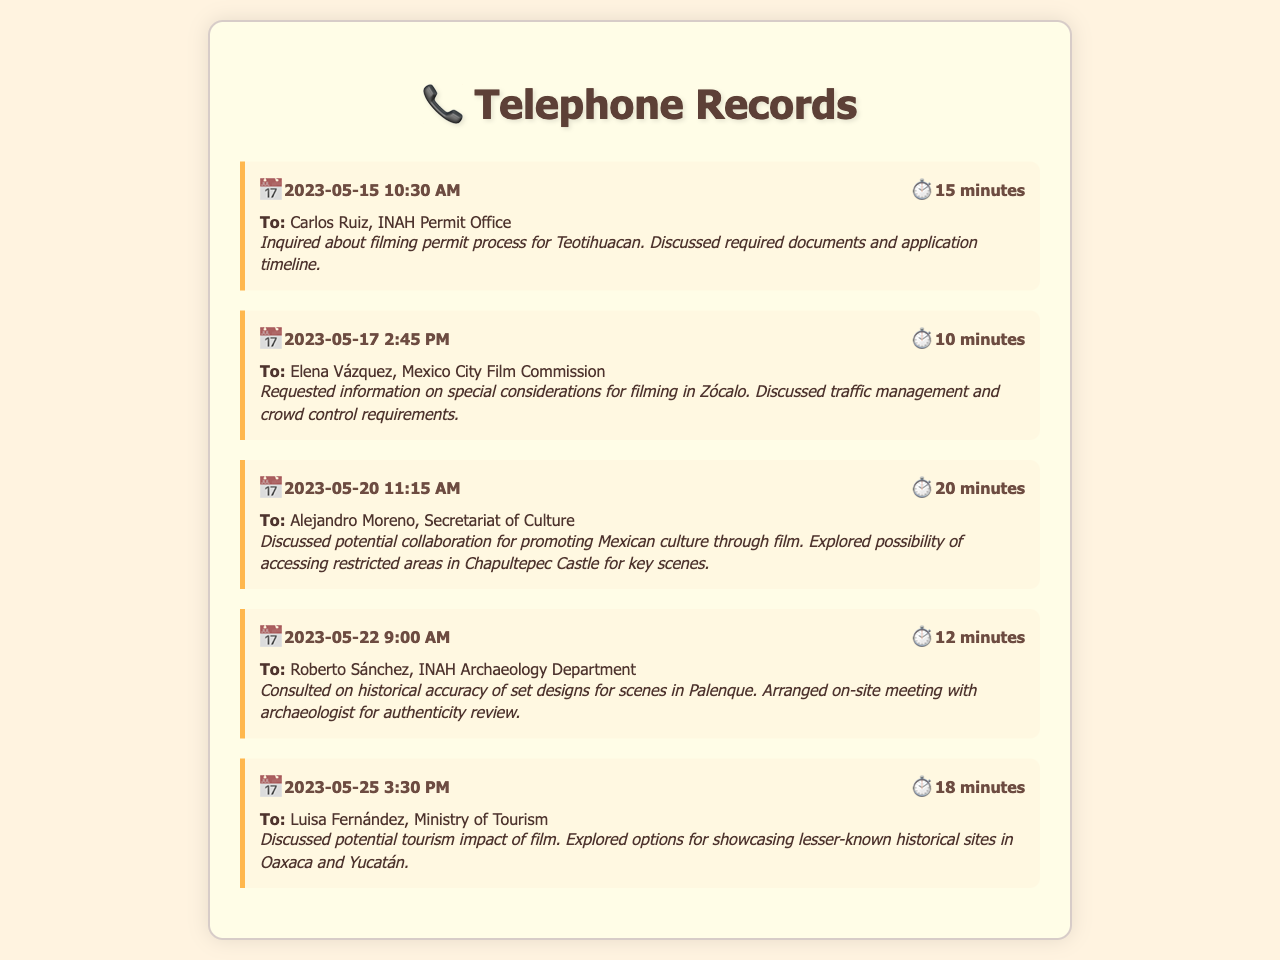What is the date of the first call? The date of the first call is mentioned in the call record as May 15, 2023.
Answer: May 15, 2023 Who did María González speak to on May 20, 2023? The document lists Alejandro Moreno as the person she spoke to on that date.
Answer: Alejandro Moreno What was the duration of the call with Elena Vázquez? The duration is provided in the call record as 10 minutes.
Answer: 10 minutes What location was discussed for filming in the call with Carlos Ruiz? The location discussed in the call is Teotihuacan.
Answer: Teotihuacan What is one of the topics discussed with Luisa Fernández? The document mentions exploring options for showcasing lesser-known historical sites as a topic of discussion.
Answer: Tourism impact How many minutes did the conversation with Roberto Sánchez last? The call duration for Roberto Sánchez is recorded as 12 minutes.
Answer: 12 minutes Which agency does Carlos Ruiz work for? The telephone record specifies that Carlos Ruiz works at the INAH Permit Office.
Answer: INAH Permit Office What was the primary concern discussed with Elena Vázquez? The primary concern was traffic management and crowd control requirements.
Answer: Traffic management What kind of collaboration was explored with Alejandro Moreno? The exploration was about promoting Mexican culture through film.
Answer: Promoting Mexican culture 